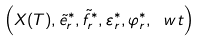<formula> <loc_0><loc_0><loc_500><loc_500>\left ( X ( T ) , \tilde { e } _ { r } ^ { * } , \tilde { f } _ { r } ^ { * } , \varepsilon _ { r } ^ { * } , \varphi _ { r } ^ { * } , \ w t \right )</formula> 